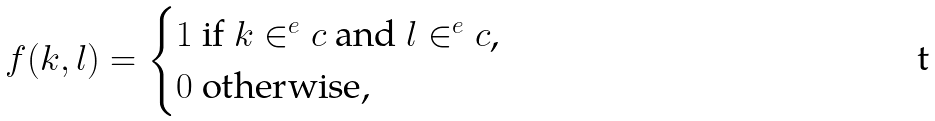<formula> <loc_0><loc_0><loc_500><loc_500>f ( k , l ) = \begin{cases} 1 \text { if $k\in^{e}c$ and $l\in^{e}c$,} \\ 0 \text { otherwise,} \end{cases}</formula> 